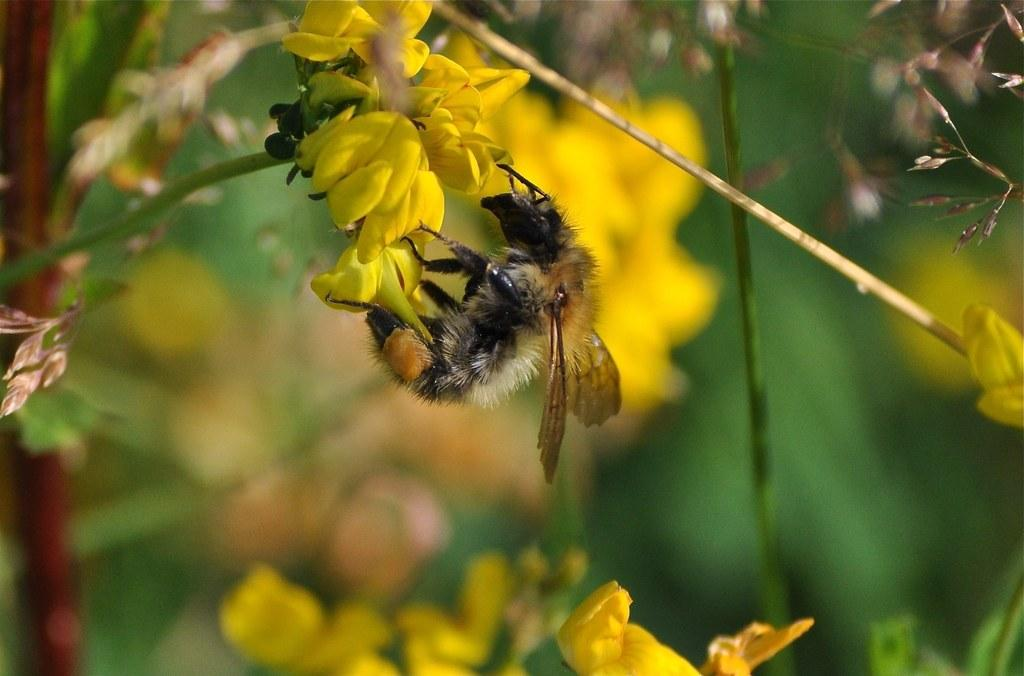What is the insect sitting on in the image? There is an insect on a yellow flower in the image. What part of the flower does the insect appear to be on? The insect is on the yellow petals of the flower. What supports the flower in the image? The flower has a stem. What can be seen in the background of the image? There is: There is greenery and flowers visible in the background of the image. What type of business does the insect's grandmother own in the image? There is no information about the insect's grandmother or any business in the image. How many legs does the insect have in the image? The image does not show the insect's legs, so it cannot be determined from the image. 